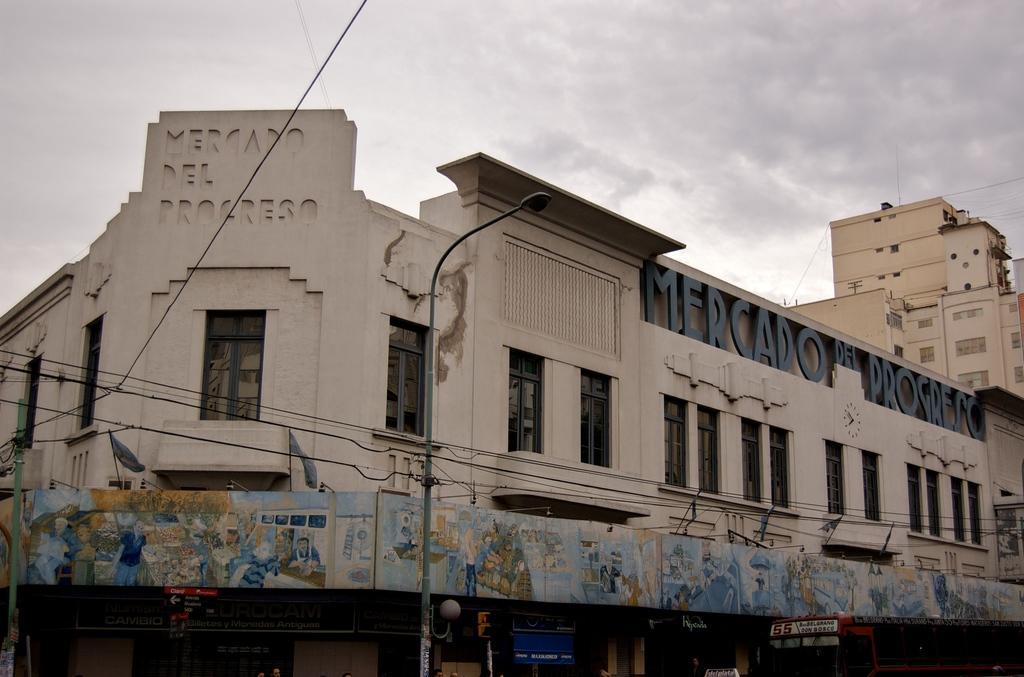In one or two sentences, can you explain what this image depicts? In the image there is a building, below the building there is a vehicle, a traffic signal pole, a street light and there is another tall building on the right side. 